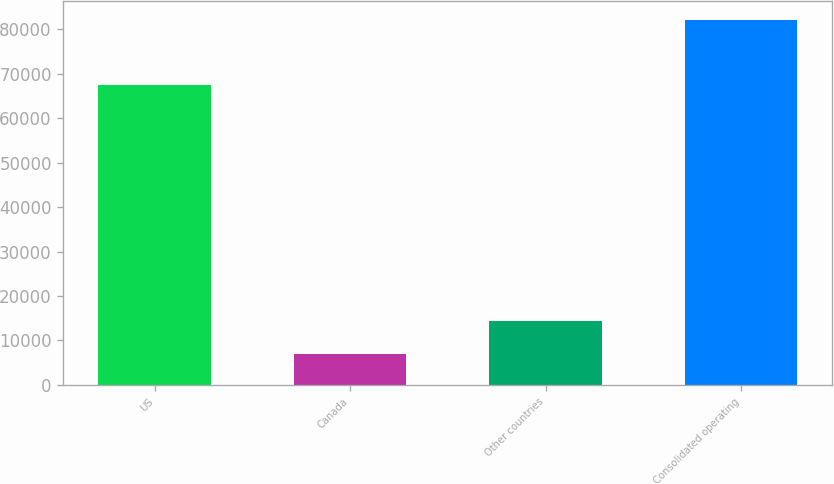Convert chart to OTSL. <chart><loc_0><loc_0><loc_500><loc_500><bar_chart><fcel>US<fcel>Canada<fcel>Other countries<fcel>Consolidated operating<nl><fcel>67392<fcel>6945<fcel>14473.8<fcel>82233<nl></chart> 